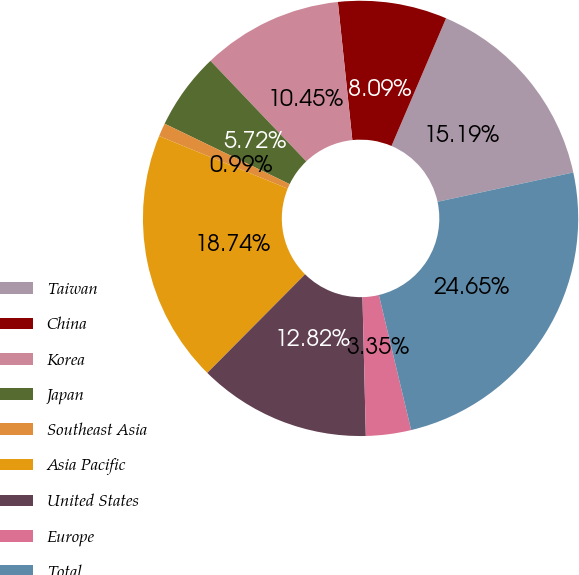Convert chart. <chart><loc_0><loc_0><loc_500><loc_500><pie_chart><fcel>Taiwan<fcel>China<fcel>Korea<fcel>Japan<fcel>Southeast Asia<fcel>Asia Pacific<fcel>United States<fcel>Europe<fcel>Total<nl><fcel>15.19%<fcel>8.09%<fcel>10.45%<fcel>5.72%<fcel>0.99%<fcel>18.74%<fcel>12.82%<fcel>3.35%<fcel>24.65%<nl></chart> 